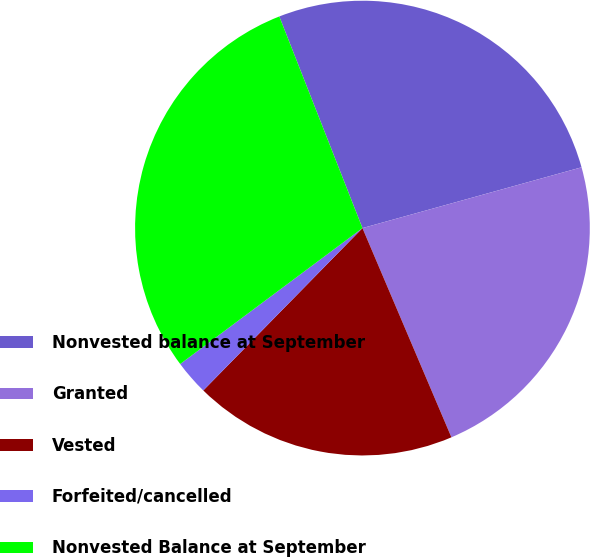Convert chart. <chart><loc_0><loc_0><loc_500><loc_500><pie_chart><fcel>Nonvested balance at September<fcel>Granted<fcel>Vested<fcel>Forfeited/cancelled<fcel>Nonvested Balance at September<nl><fcel>26.65%<fcel>22.91%<fcel>18.74%<fcel>2.46%<fcel>29.24%<nl></chart> 